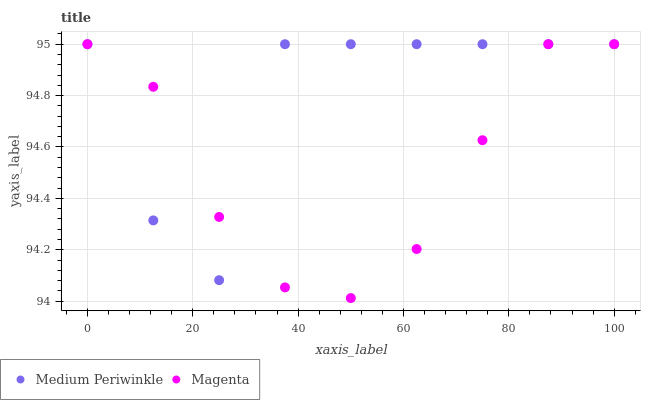Does Magenta have the minimum area under the curve?
Answer yes or no. Yes. Does Medium Periwinkle have the maximum area under the curve?
Answer yes or no. Yes. Does Medium Periwinkle have the minimum area under the curve?
Answer yes or no. No. Is Magenta the smoothest?
Answer yes or no. Yes. Is Medium Periwinkle the roughest?
Answer yes or no. Yes. Is Medium Periwinkle the smoothest?
Answer yes or no. No. Does Magenta have the lowest value?
Answer yes or no. Yes. Does Medium Periwinkle have the lowest value?
Answer yes or no. No. Does Medium Periwinkle have the highest value?
Answer yes or no. Yes. Does Magenta intersect Medium Periwinkle?
Answer yes or no. Yes. Is Magenta less than Medium Periwinkle?
Answer yes or no. No. Is Magenta greater than Medium Periwinkle?
Answer yes or no. No. 